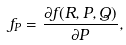<formula> <loc_0><loc_0><loc_500><loc_500>f _ { P } = \frac { \partial f ( R , P , Q ) } { \partial P } ,</formula> 